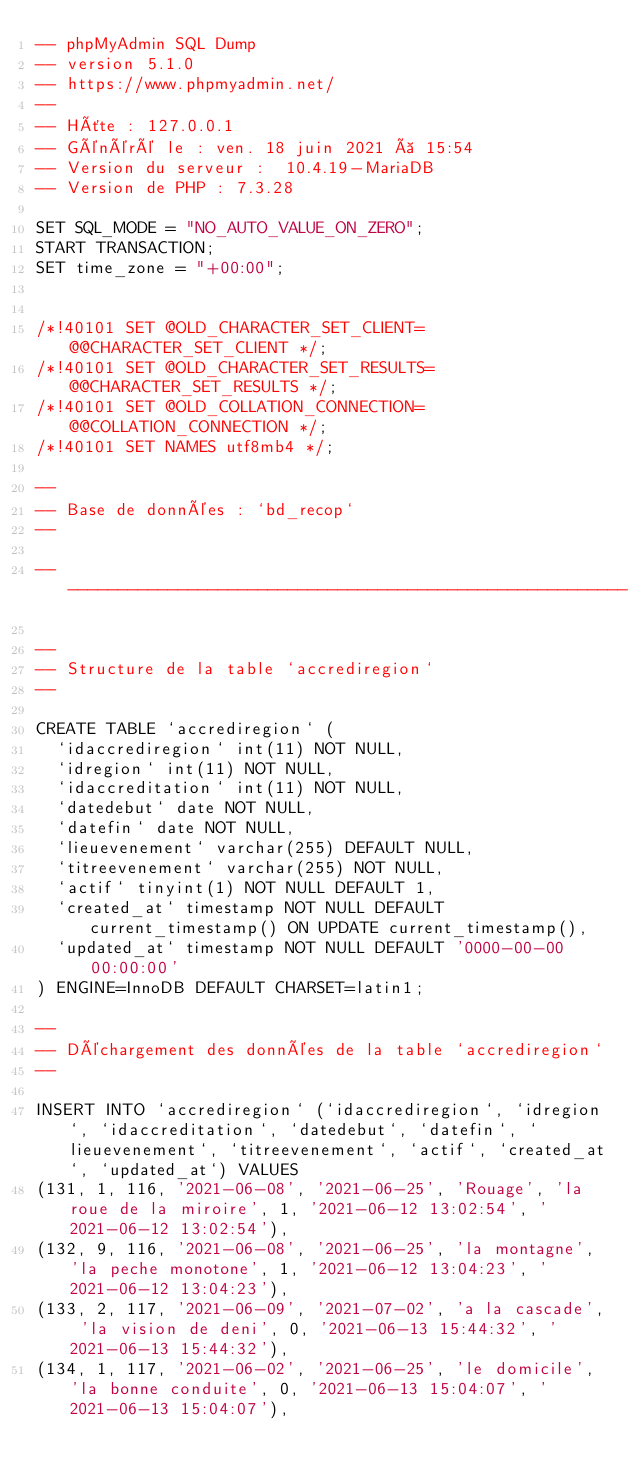<code> <loc_0><loc_0><loc_500><loc_500><_SQL_>-- phpMyAdmin SQL Dump
-- version 5.1.0
-- https://www.phpmyadmin.net/
--
-- Hôte : 127.0.0.1
-- Généré le : ven. 18 juin 2021 à 15:54
-- Version du serveur :  10.4.19-MariaDB
-- Version de PHP : 7.3.28

SET SQL_MODE = "NO_AUTO_VALUE_ON_ZERO";
START TRANSACTION;
SET time_zone = "+00:00";


/*!40101 SET @OLD_CHARACTER_SET_CLIENT=@@CHARACTER_SET_CLIENT */;
/*!40101 SET @OLD_CHARACTER_SET_RESULTS=@@CHARACTER_SET_RESULTS */;
/*!40101 SET @OLD_COLLATION_CONNECTION=@@COLLATION_CONNECTION */;
/*!40101 SET NAMES utf8mb4 */;

--
-- Base de données : `bd_recop`
--

-- --------------------------------------------------------

--
-- Structure de la table `accrediregion`
--

CREATE TABLE `accrediregion` (
  `idaccrediregion` int(11) NOT NULL,
  `idregion` int(11) NOT NULL,
  `idaccreditation` int(11) NOT NULL,
  `datedebut` date NOT NULL,
  `datefin` date NOT NULL,
  `lieuevenement` varchar(255) DEFAULT NULL,
  `titreevenement` varchar(255) NOT NULL,
  `actif` tinyint(1) NOT NULL DEFAULT 1,
  `created_at` timestamp NOT NULL DEFAULT current_timestamp() ON UPDATE current_timestamp(),
  `updated_at` timestamp NOT NULL DEFAULT '0000-00-00 00:00:00'
) ENGINE=InnoDB DEFAULT CHARSET=latin1;

--
-- Déchargement des données de la table `accrediregion`
--

INSERT INTO `accrediregion` (`idaccrediregion`, `idregion`, `idaccreditation`, `datedebut`, `datefin`, `lieuevenement`, `titreevenement`, `actif`, `created_at`, `updated_at`) VALUES
(131, 1, 116, '2021-06-08', '2021-06-25', 'Rouage', 'la roue de la miroire', 1, '2021-06-12 13:02:54', '2021-06-12 13:02:54'),
(132, 9, 116, '2021-06-08', '2021-06-25', 'la montagne', 'la peche monotone', 1, '2021-06-12 13:04:23', '2021-06-12 13:04:23'),
(133, 2, 117, '2021-06-09', '2021-07-02', 'a la cascade', 'la vision de deni', 0, '2021-06-13 15:44:32', '2021-06-13 15:44:32'),
(134, 1, 117, '2021-06-02', '2021-06-25', 'le domicile', 'la bonne conduite', 0, '2021-06-13 15:04:07', '2021-06-13 15:04:07'),</code> 